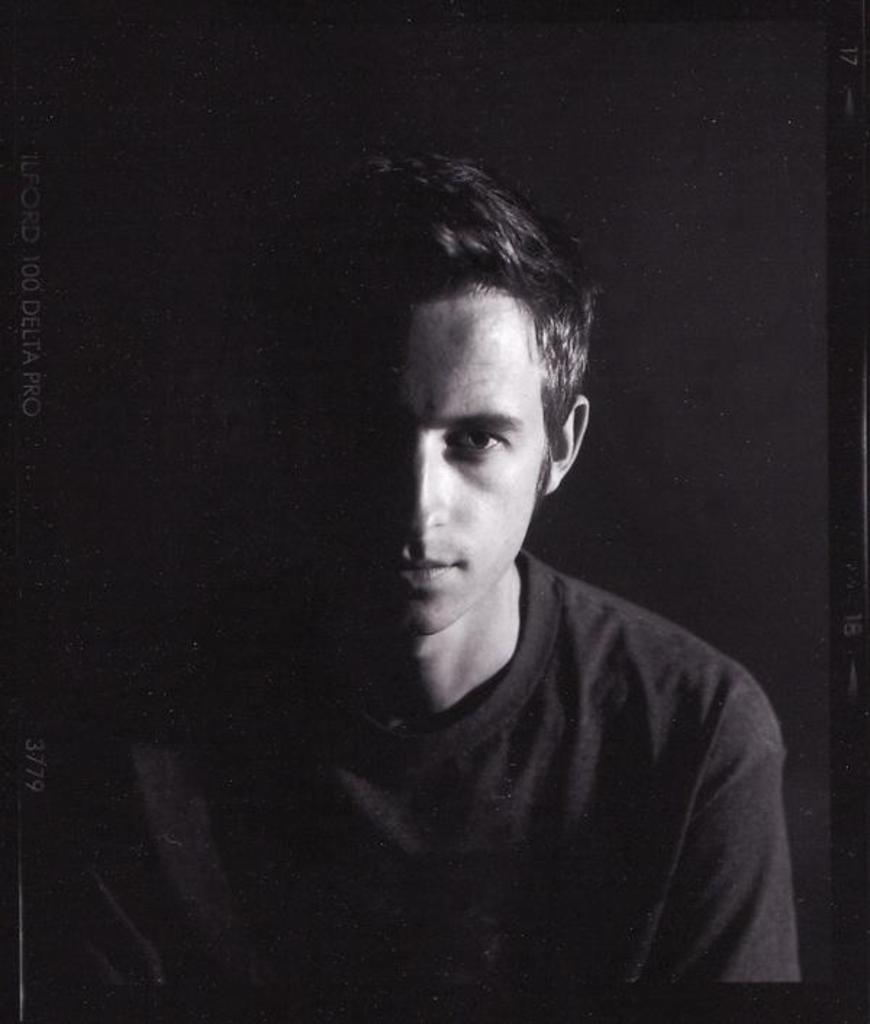Who or what is present in the image? There is a person in the image. What can be observed about the environment in the image? The background of the image is dark. What type of bottle is being held by the deer in the image? There is no deer or bottle present in the image; it only features a person with a dark background. 